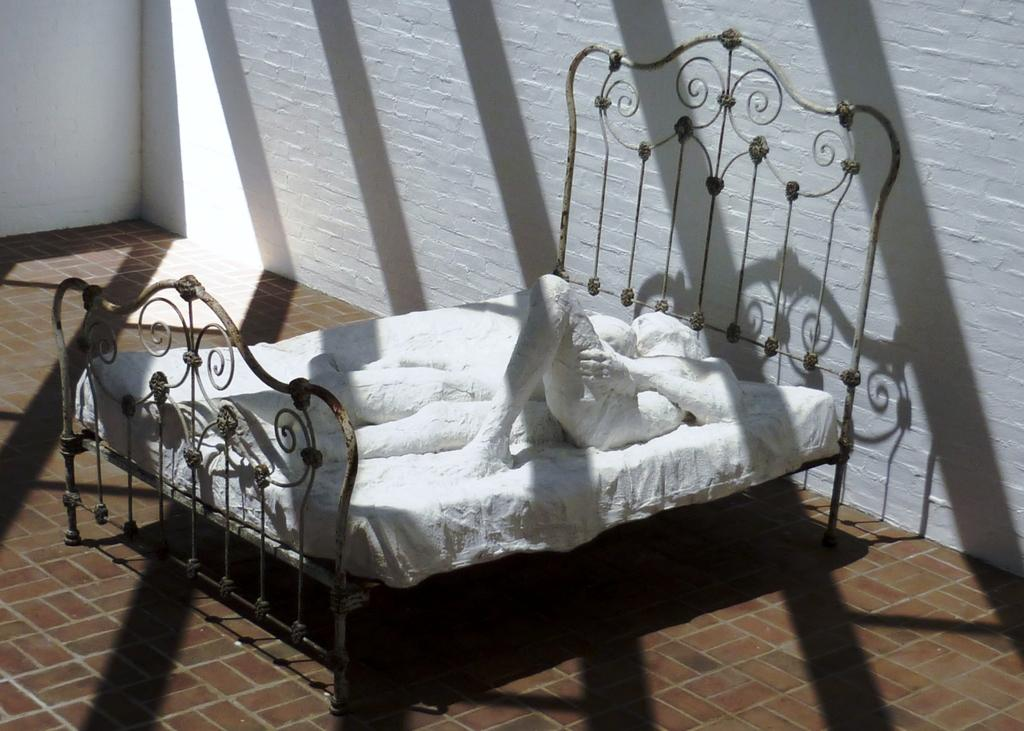What is placed on the floor in the image? There is a cot on the floor in the image. What is on top of the cot? There is a statue on the cot. What can be seen in the background of the image? The background of the image includes walls. How does the mom interact with the statue on the cot during the trip? There is no mention of a mom or a trip in the image, so it is not possible to answer that question. 